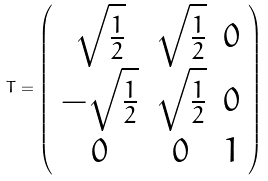Convert formula to latex. <formula><loc_0><loc_0><loc_500><loc_500>T = \left ( \begin{array} { c c c } \sqrt { \frac { 1 } { 2 } } & \sqrt { \frac { 1 } { 2 } } & 0 \\ - \sqrt { \frac { 1 } { 2 } } & \sqrt { \frac { 1 } { 2 } } & 0 \\ 0 & 0 & 1 \\ \end{array} \right )</formula> 